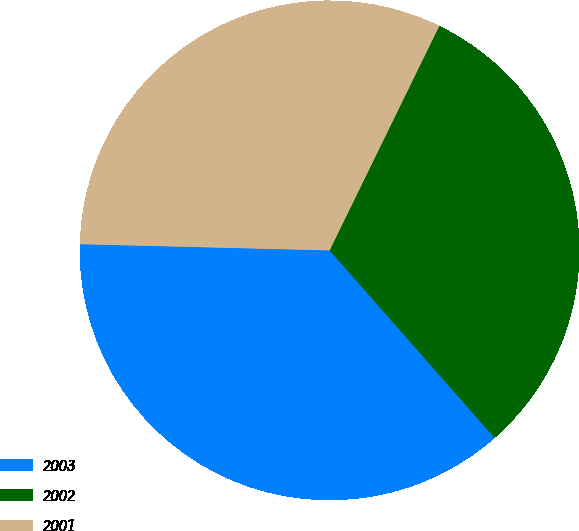Convert chart. <chart><loc_0><loc_0><loc_500><loc_500><pie_chart><fcel>2003<fcel>2002<fcel>2001<nl><fcel>36.88%<fcel>31.28%<fcel>31.84%<nl></chart> 